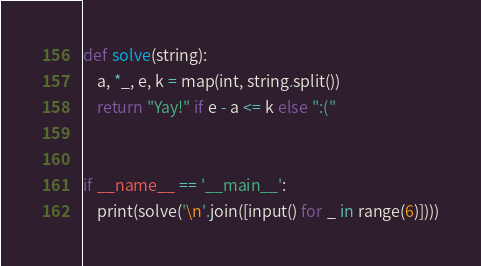Convert code to text. <code><loc_0><loc_0><loc_500><loc_500><_Python_>def solve(string):
    a, *_, e, k = map(int, string.split())
    return "Yay!" if e - a <= k else ":("


if __name__ == '__main__':
    print(solve('\n'.join([input() for _ in range(6)])))
</code> 